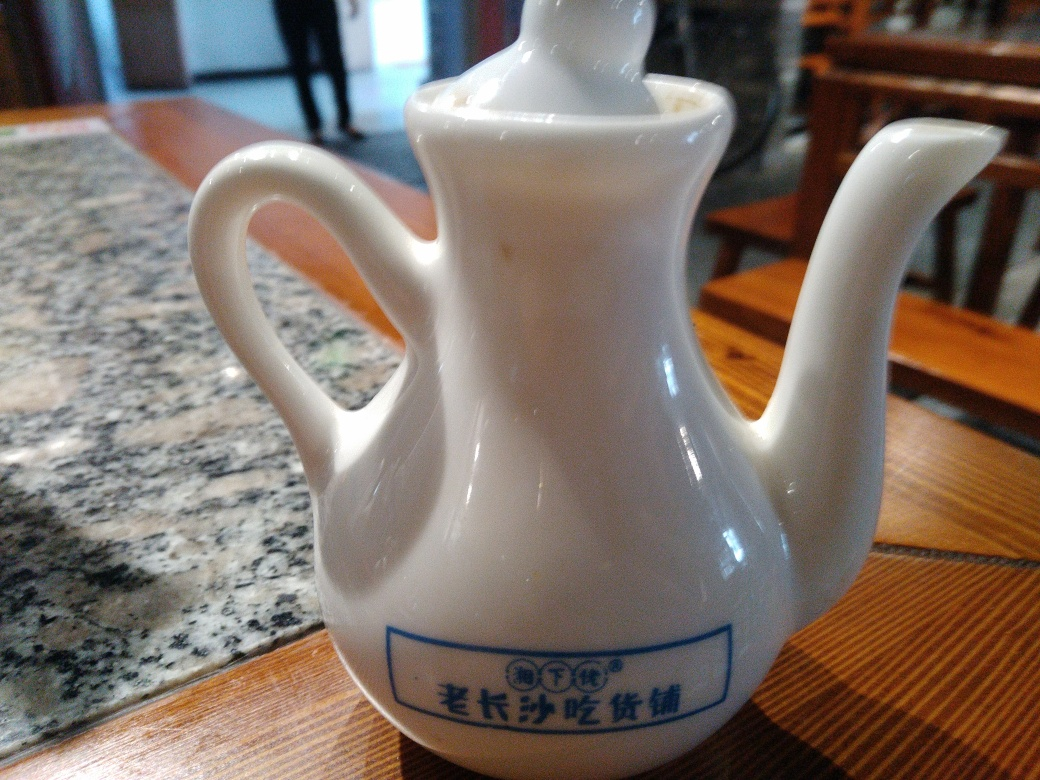Can you describe the object in the image and its possible use? The image displays a white porcelain teapot with a graceful design, typically used for brewing and serving tea. Its shape, including a curved handle and spout, indicates it is crafted to pour liquid smoothly. The writing and symbols on the side suggest a cultural significance or branding, possibly alluding to a particular style or region associated with tea-making. 